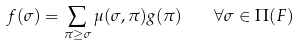Convert formula to latex. <formula><loc_0><loc_0><loc_500><loc_500>f ( \sigma ) = \sum _ { \pi \geq \sigma } \mu ( \sigma , \pi ) g ( \pi ) \quad \forall \sigma \in \Pi ( F )</formula> 